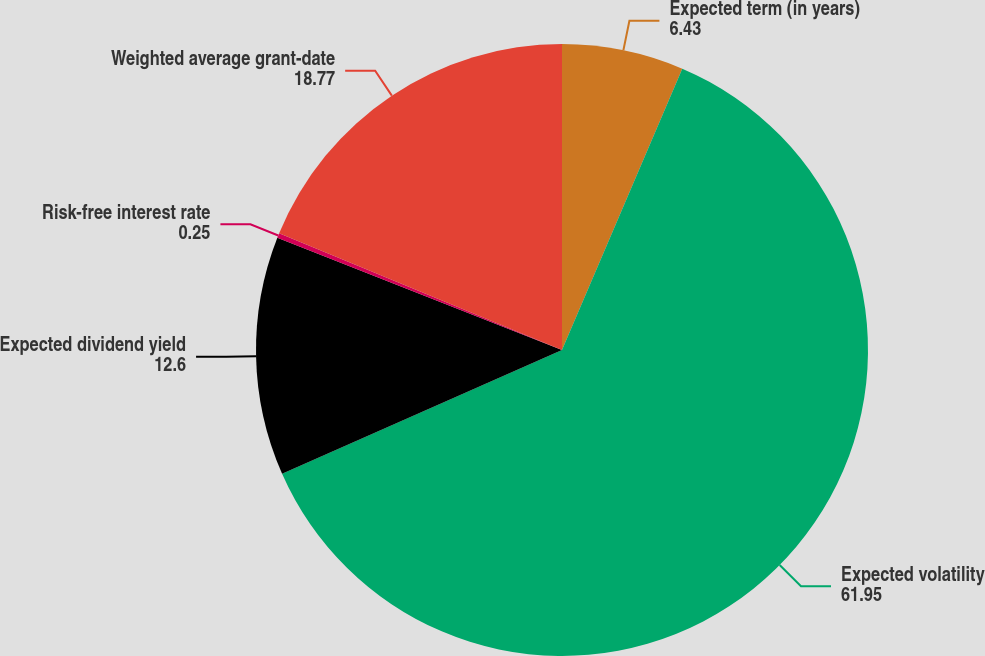<chart> <loc_0><loc_0><loc_500><loc_500><pie_chart><fcel>Expected term (in years)<fcel>Expected volatility<fcel>Expected dividend yield<fcel>Risk-free interest rate<fcel>Weighted average grant-date<nl><fcel>6.43%<fcel>61.95%<fcel>12.6%<fcel>0.25%<fcel>18.77%<nl></chart> 